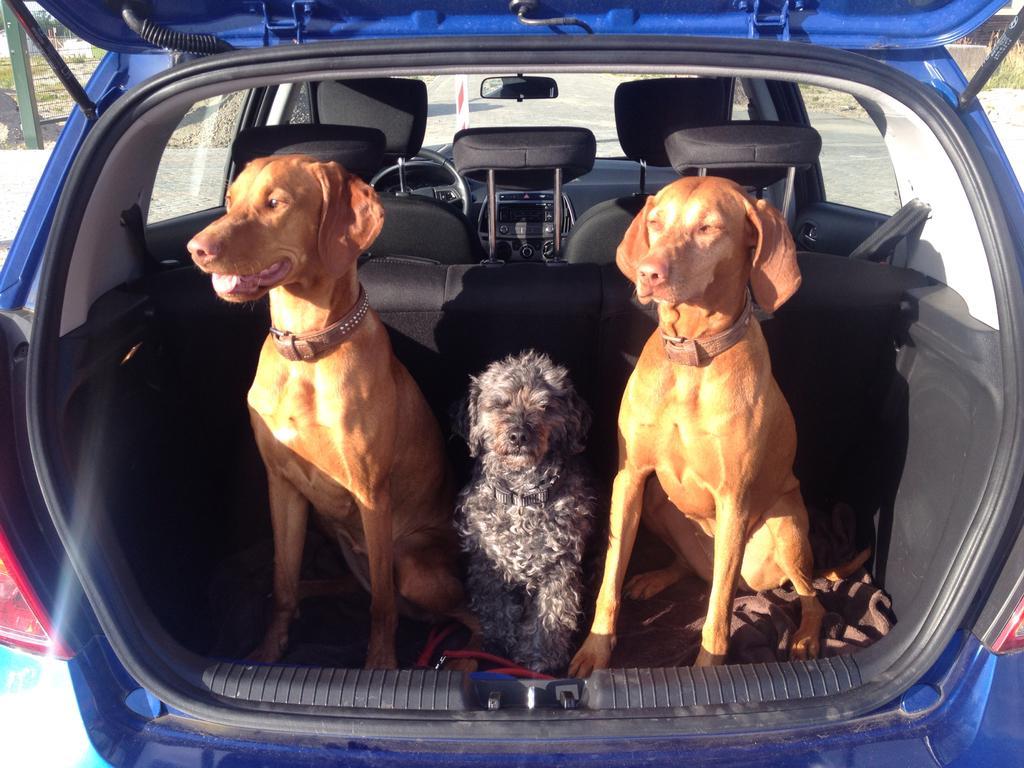Can you describe this image briefly? This picture describes about three dogs and these three dogs are in the car in the background we can see a pole and couple of trees. 